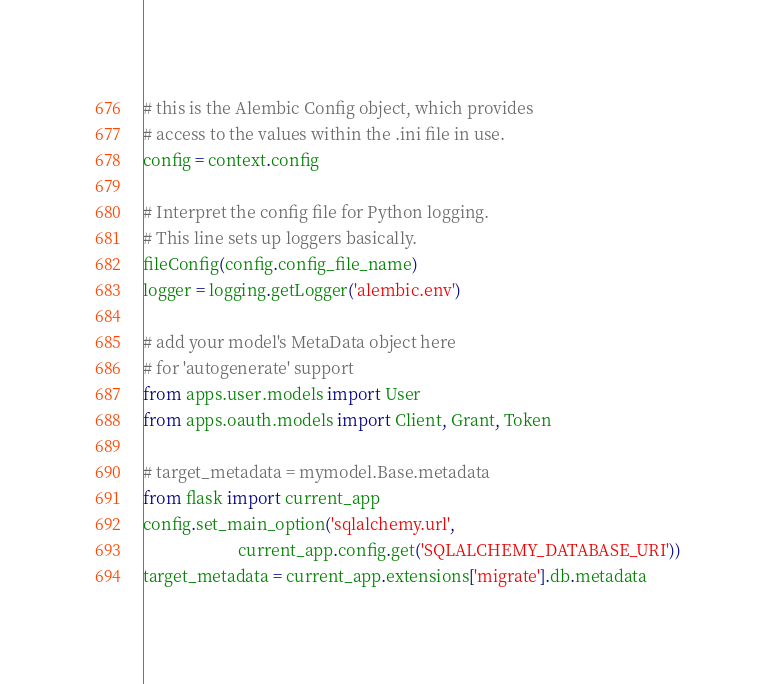<code> <loc_0><loc_0><loc_500><loc_500><_Python_>
# this is the Alembic Config object, which provides
# access to the values within the .ini file in use.
config = context.config

# Interpret the config file for Python logging.
# This line sets up loggers basically.
fileConfig(config.config_file_name)
logger = logging.getLogger('alembic.env')

# add your model's MetaData object here
# for 'autogenerate' support
from apps.user.models import User
from apps.oauth.models import Client, Grant, Token

# target_metadata = mymodel.Base.metadata
from flask import current_app
config.set_main_option('sqlalchemy.url',
                       current_app.config.get('SQLALCHEMY_DATABASE_URI'))
target_metadata = current_app.extensions['migrate'].db.metadata
</code> 